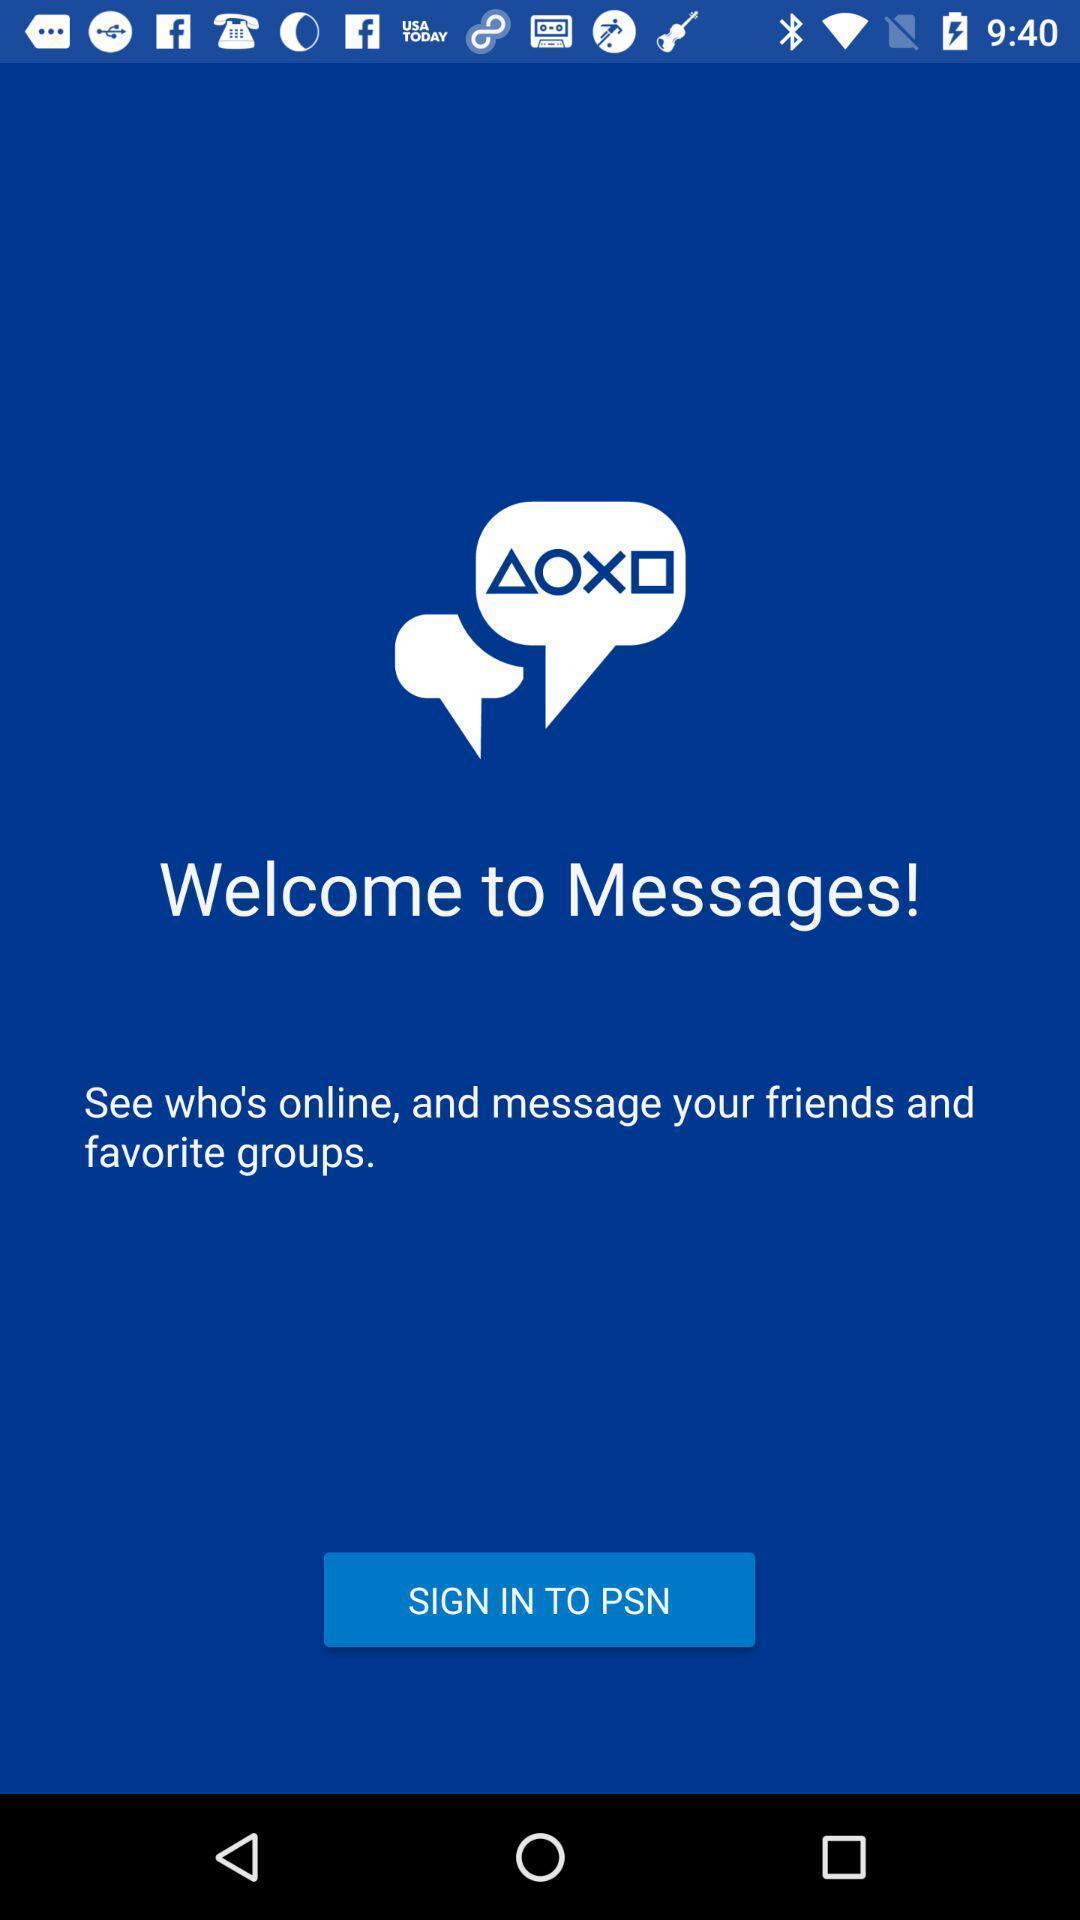What details can you identify in this image? Welcome page showing about sign in option. 